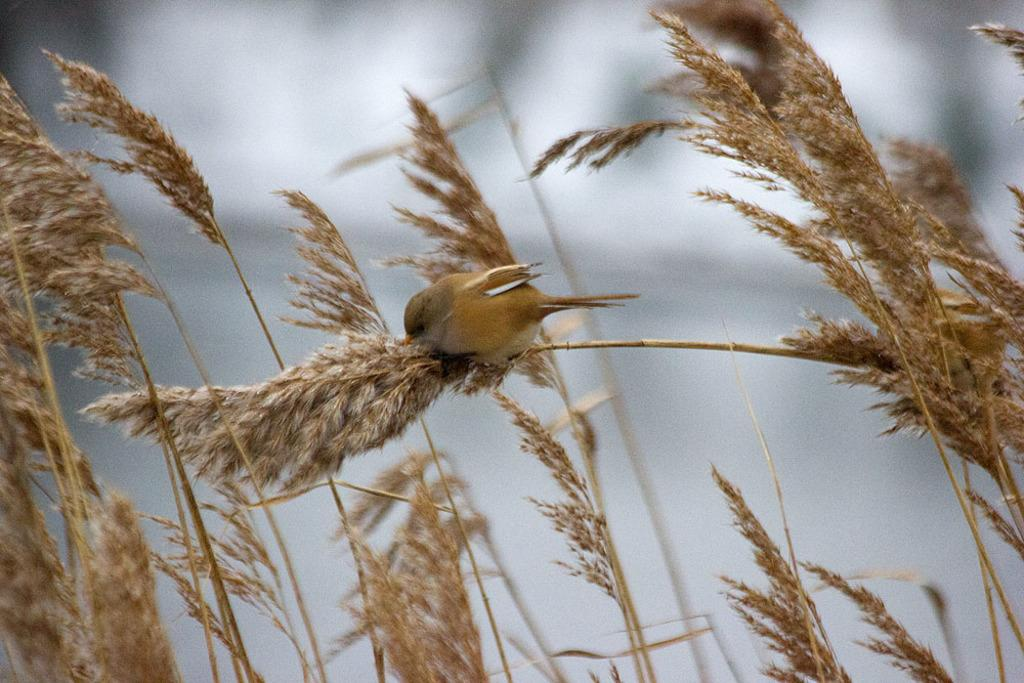What type of animal is present in the image? There is a bird in the image. Where is the bird located in the image? The bird is on the plants. Can you describe the background of the image? The background of the image is blurred. What type of desk can be seen in the image? There is no desk present in the image. Can you tell me how many cows are visible in the image? There are no cows present in the image. 